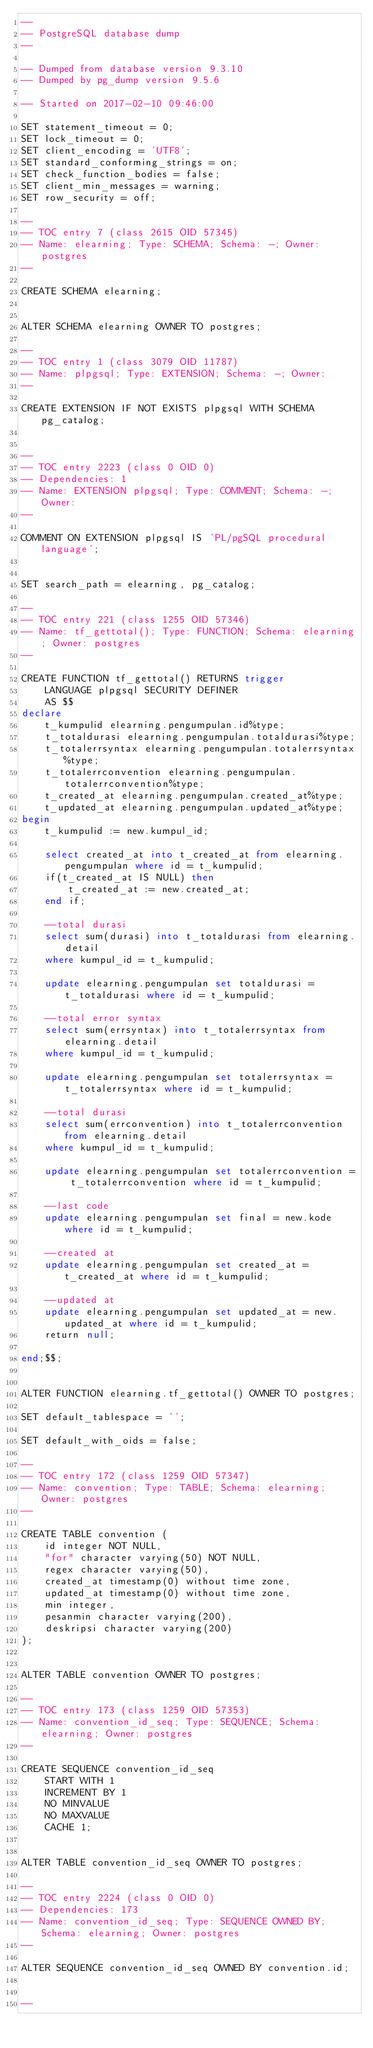Convert code to text. <code><loc_0><loc_0><loc_500><loc_500><_SQL_>--
-- PostgreSQL database dump
--

-- Dumped from database version 9.3.10
-- Dumped by pg_dump version 9.5.6

-- Started on 2017-02-10 09:46:00

SET statement_timeout = 0;
SET lock_timeout = 0;
SET client_encoding = 'UTF8';
SET standard_conforming_strings = on;
SET check_function_bodies = false;
SET client_min_messages = warning;
SET row_security = off;

--
-- TOC entry 7 (class 2615 OID 57345)
-- Name: elearning; Type: SCHEMA; Schema: -; Owner: postgres
--

CREATE SCHEMA elearning;


ALTER SCHEMA elearning OWNER TO postgres;

--
-- TOC entry 1 (class 3079 OID 11787)
-- Name: plpgsql; Type: EXTENSION; Schema: -; Owner: 
--

CREATE EXTENSION IF NOT EXISTS plpgsql WITH SCHEMA pg_catalog;


--
-- TOC entry 2223 (class 0 OID 0)
-- Dependencies: 1
-- Name: EXTENSION plpgsql; Type: COMMENT; Schema: -; Owner: 
--

COMMENT ON EXTENSION plpgsql IS 'PL/pgSQL procedural language';


SET search_path = elearning, pg_catalog;

--
-- TOC entry 221 (class 1255 OID 57346)
-- Name: tf_gettotal(); Type: FUNCTION; Schema: elearning; Owner: postgres
--

CREATE FUNCTION tf_gettotal() RETURNS trigger
    LANGUAGE plpgsql SECURITY DEFINER
    AS $$
declare
	t_kumpulid elearning.pengumpulan.id%type;
	t_totaldurasi elearning.pengumpulan.totaldurasi%type;
	t_totalerrsyntax elearning.pengumpulan.totalerrsyntax%type;
	t_totalerrconvention elearning.pengumpulan.totalerrconvention%type;
	t_created_at elearning.pengumpulan.created_at%type;
	t_updated_at elearning.pengumpulan.updated_at%type;
begin
	t_kumpulid := new.kumpul_id;

	select created_at into t_created_at from elearning.pengumpulan where id = t_kumpulid;
	if(t_created_at IS NULL) then
		t_created_at := new.created_at;
	end if;

	--total durasi
	select sum(durasi) into t_totaldurasi from elearning.detail
	where kumpul_id = t_kumpulid;
		
	update elearning.pengumpulan set totaldurasi = t_totaldurasi where id = t_kumpulid;

	--total error syntax
	select sum(errsyntax) into t_totalerrsyntax from elearning.detail
	where kumpul_id = t_kumpulid;
		
	update elearning.pengumpulan set totalerrsyntax = t_totalerrsyntax where id = t_kumpulid;

	--total durasi
	select sum(errconvention) into t_totalerrconvention from elearning.detail
	where kumpul_id = t_kumpulid;
		
	update elearning.pengumpulan set totalerrconvention = t_totalerrconvention where id = t_kumpulid;

	--last code
	update elearning.pengumpulan set final = new.kode where id = t_kumpulid;
	
	--created at
	update elearning.pengumpulan set created_at = t_created_at where id = t_kumpulid;

	--updated at
	update elearning.pengumpulan set updated_at = new.updated_at where id = t_kumpulid;
	return null;

end;$$;


ALTER FUNCTION elearning.tf_gettotal() OWNER TO postgres;

SET default_tablespace = '';

SET default_with_oids = false;

--
-- TOC entry 172 (class 1259 OID 57347)
-- Name: convention; Type: TABLE; Schema: elearning; Owner: postgres
--

CREATE TABLE convention (
    id integer NOT NULL,
    "for" character varying(50) NOT NULL,
    regex character varying(50),
    created_at timestamp(0) without time zone,
    updated_at timestamp(0) without time zone,
    min integer,
    pesanmin character varying(200),
    deskripsi character varying(200)
);


ALTER TABLE convention OWNER TO postgres;

--
-- TOC entry 173 (class 1259 OID 57353)
-- Name: convention_id_seq; Type: SEQUENCE; Schema: elearning; Owner: postgres
--

CREATE SEQUENCE convention_id_seq
    START WITH 1
    INCREMENT BY 1
    NO MINVALUE
    NO MAXVALUE
    CACHE 1;


ALTER TABLE convention_id_seq OWNER TO postgres;

--
-- TOC entry 2224 (class 0 OID 0)
-- Dependencies: 173
-- Name: convention_id_seq; Type: SEQUENCE OWNED BY; Schema: elearning; Owner: postgres
--

ALTER SEQUENCE convention_id_seq OWNED BY convention.id;


--</code> 